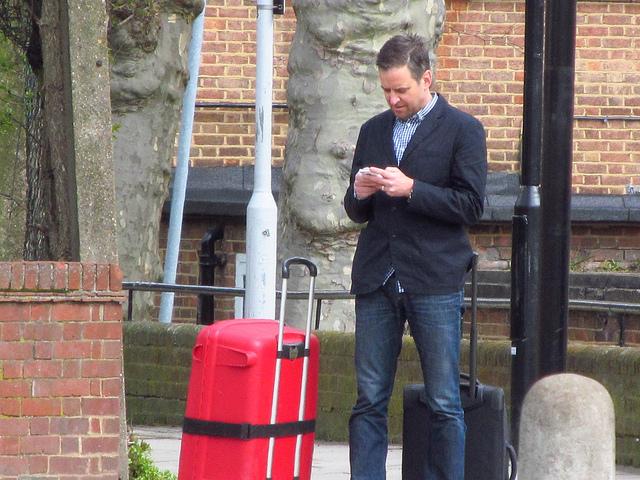Do the suitcases have wheels?
Concise answer only. Yes. Is the brick wall waist height?
Short answer required. Yes. Is this man on the right standing near luggage?
Write a very short answer. Yes. 